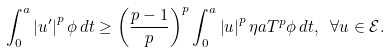<formula> <loc_0><loc_0><loc_500><loc_500>\int _ { 0 } ^ { a } \left | u ^ { \prime } \right | ^ { p } \phi \, d t \geq \left ( \frac { p - 1 } { p } \right ) ^ { p } \int _ { 0 } ^ { a } \left | u \right | ^ { p } \eta a T ^ { p } \phi \, d t , \ \forall u \in \mathcal { E } .</formula> 